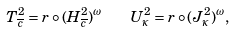Convert formula to latex. <formula><loc_0><loc_0><loc_500><loc_500>T ^ { 2 } _ { \overline { c } } = r \circ ( H ^ { 2 } _ { \overline { c } } ) ^ { \omega } \quad U ^ { 2 } _ { \kappa } = r \circ ( J ^ { 2 } _ { \kappa } ) ^ { \omega } ,</formula> 